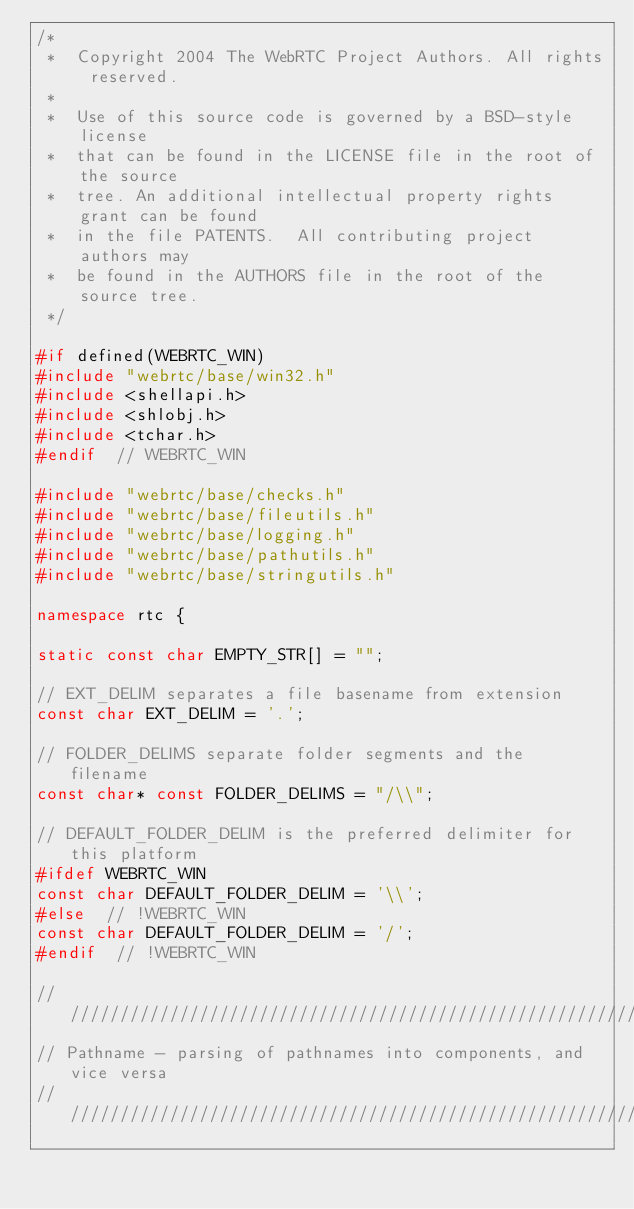Convert code to text. <code><loc_0><loc_0><loc_500><loc_500><_C++_>/*
 *  Copyright 2004 The WebRTC Project Authors. All rights reserved.
 *
 *  Use of this source code is governed by a BSD-style license
 *  that can be found in the LICENSE file in the root of the source
 *  tree. An additional intellectual property rights grant can be found
 *  in the file PATENTS.  All contributing project authors may
 *  be found in the AUTHORS file in the root of the source tree.
 */

#if defined(WEBRTC_WIN)
#include "webrtc/base/win32.h"
#include <shellapi.h>
#include <shlobj.h>
#include <tchar.h>
#endif  // WEBRTC_WIN

#include "webrtc/base/checks.h"
#include "webrtc/base/fileutils.h"
#include "webrtc/base/logging.h"
#include "webrtc/base/pathutils.h"
#include "webrtc/base/stringutils.h"

namespace rtc {

static const char EMPTY_STR[] = "";

// EXT_DELIM separates a file basename from extension
const char EXT_DELIM = '.';

// FOLDER_DELIMS separate folder segments and the filename
const char* const FOLDER_DELIMS = "/\\";

// DEFAULT_FOLDER_DELIM is the preferred delimiter for this platform
#ifdef WEBRTC_WIN
const char DEFAULT_FOLDER_DELIM = '\\';
#else  // !WEBRTC_WIN
const char DEFAULT_FOLDER_DELIM = '/';
#endif  // !WEBRTC_WIN

///////////////////////////////////////////////////////////////////////////////
// Pathname - parsing of pathnames into components, and vice versa
///////////////////////////////////////////////////////////////////////////////
</code> 